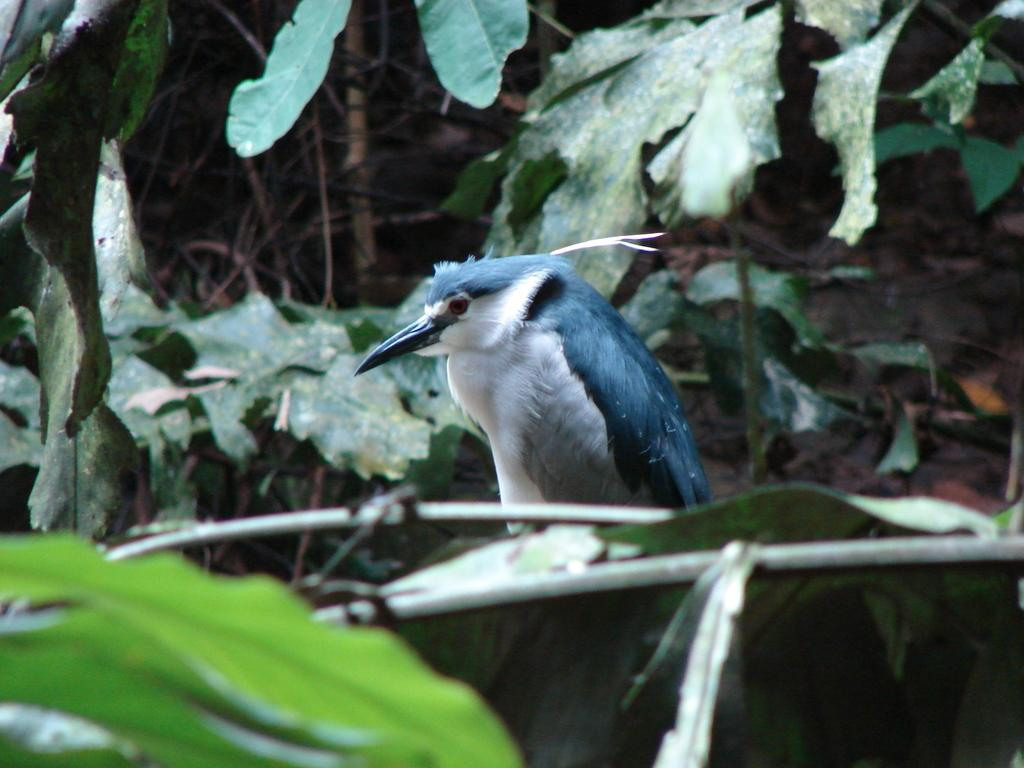What type of animal can be seen in the image? There is a bird in the image. What else is present in the image besides the bird? There are stems and green leaves in the image. What is the development stage of the arm in the image? There is no arm present in the image; it features a bird, stems, and green leaves. 